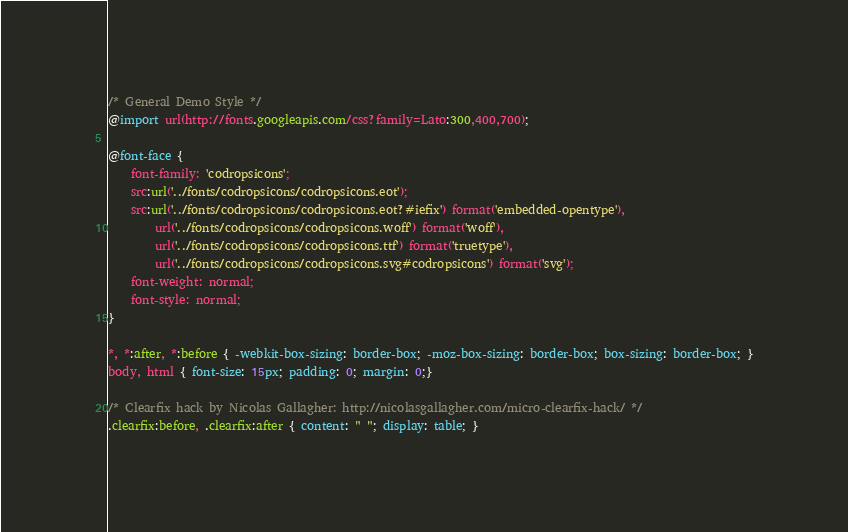<code> <loc_0><loc_0><loc_500><loc_500><_CSS_>/* General Demo Style */
@import url(http://fonts.googleapis.com/css?family=Lato:300,400,700);

@font-face {
	font-family: 'codropsicons';
	src:url('../fonts/codropsicons/codropsicons.eot');
	src:url('../fonts/codropsicons/codropsicons.eot?#iefix') format('embedded-opentype'),
		url('../fonts/codropsicons/codropsicons.woff') format('woff'),
		url('../fonts/codropsicons/codropsicons.ttf') format('truetype'),
		url('../fonts/codropsicons/codropsicons.svg#codropsicons') format('svg');
	font-weight: normal;
	font-style: normal;
}

*, *:after, *:before { -webkit-box-sizing: border-box; -moz-box-sizing: border-box; box-sizing: border-box; }
body, html { font-size: 15px; padding: 0; margin: 0;}

/* Clearfix hack by Nicolas Gallagher: http://nicolasgallagher.com/micro-clearfix-hack/ */
.clearfix:before, .clearfix:after { content: " "; display: table; }</code> 